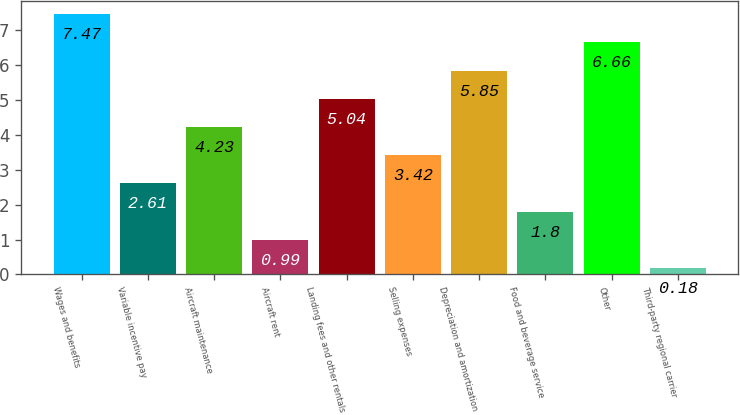<chart> <loc_0><loc_0><loc_500><loc_500><bar_chart><fcel>Wages and benefits<fcel>Variable incentive pay<fcel>Aircraft maintenance<fcel>Aircraft rent<fcel>Landing fees and other rentals<fcel>Selling expenses<fcel>Depreciation and amortization<fcel>Food and beverage service<fcel>Other<fcel>Third-party regional carrier<nl><fcel>7.47<fcel>2.61<fcel>4.23<fcel>0.99<fcel>5.04<fcel>3.42<fcel>5.85<fcel>1.8<fcel>6.66<fcel>0.18<nl></chart> 